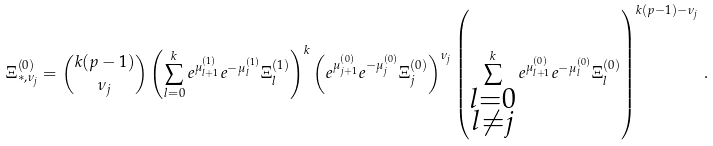<formula> <loc_0><loc_0><loc_500><loc_500>\Xi _ { * , \nu _ { j } } ^ { ( 0 ) } = { k ( p - 1 ) \choose \nu _ { j } } \left ( \sum _ { l = 0 } ^ { k } e ^ { \mu _ { l + 1 } ^ { ( 1 ) } } e ^ { - \mu _ { l } ^ { ( 1 ) } } \Xi _ { l } ^ { ( 1 ) } \right ) ^ { k } \left ( e ^ { \mu _ { j + 1 } ^ { ( 0 ) } } e ^ { - \mu _ { j } ^ { ( 0 ) } } \Xi _ { j } ^ { ( 0 ) } \right ) ^ { \nu _ { j } } \left ( \sum _ { \substack { l = 0 \\ l \neq j } } ^ { k } e ^ { \mu _ { l + 1 } ^ { ( 0 ) } } e ^ { - \mu _ { l } ^ { ( 0 ) } } \Xi _ { l } ^ { ( 0 ) } \right ) ^ { k ( p - 1 ) - \nu _ { j } } \, .</formula> 